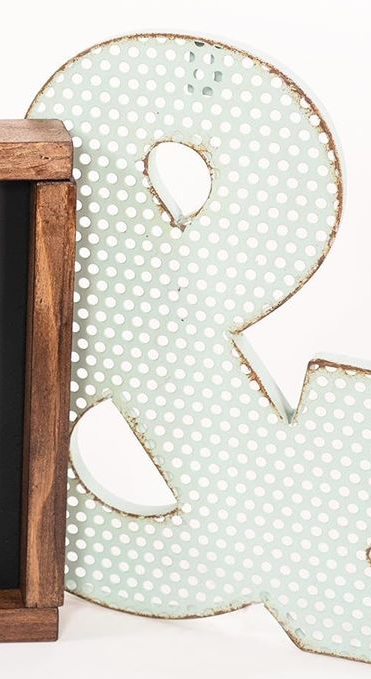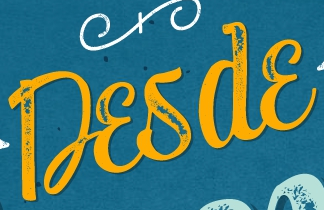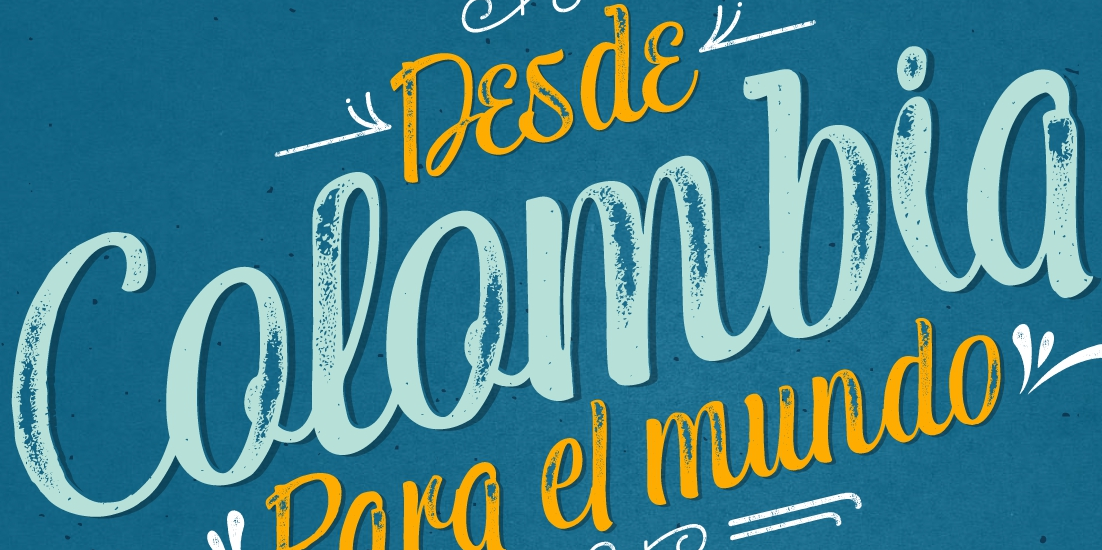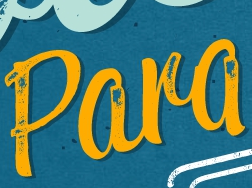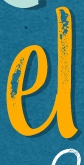What text is displayed in these images sequentially, separated by a semicolon? &; Desde; Colombia; Para; el 